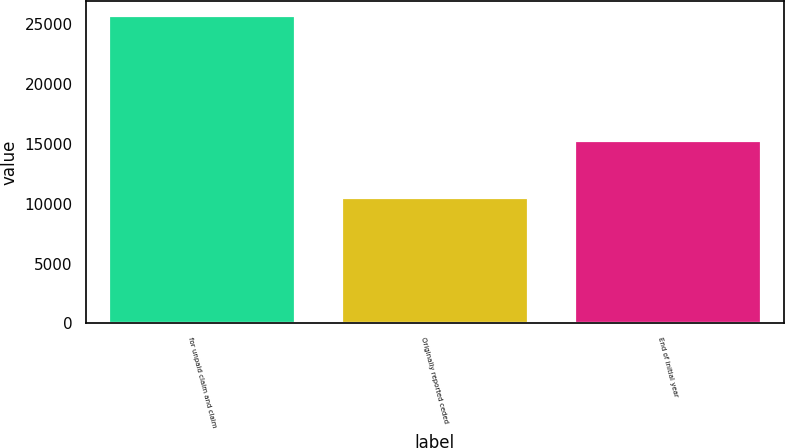<chart> <loc_0><loc_0><loc_500><loc_500><bar_chart><fcel>for unpaid claim and claim<fcel>Originally reported ceded<fcel>End of initial year<nl><fcel>25719<fcel>10490<fcel>15229<nl></chart> 